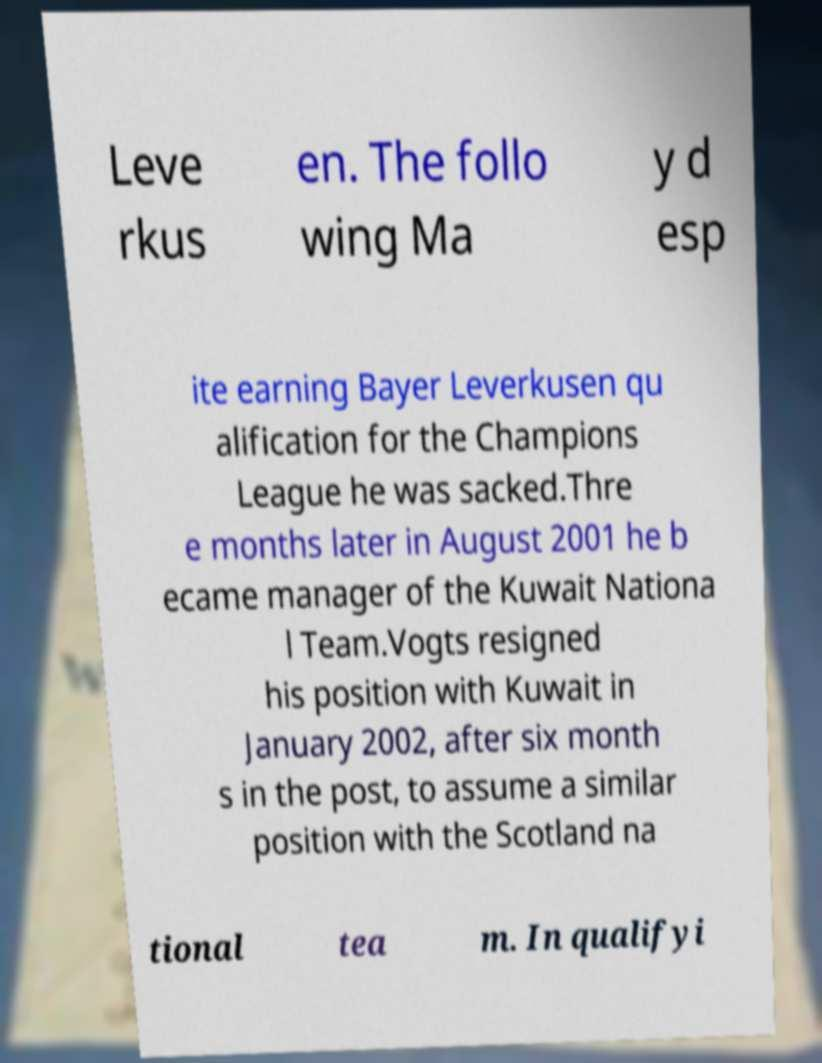Please identify and transcribe the text found in this image. Leve rkus en. The follo wing Ma y d esp ite earning Bayer Leverkusen qu alification for the Champions League he was sacked.Thre e months later in August 2001 he b ecame manager of the Kuwait Nationa l Team.Vogts resigned his position with Kuwait in January 2002, after six month s in the post, to assume a similar position with the Scotland na tional tea m. In qualifyi 